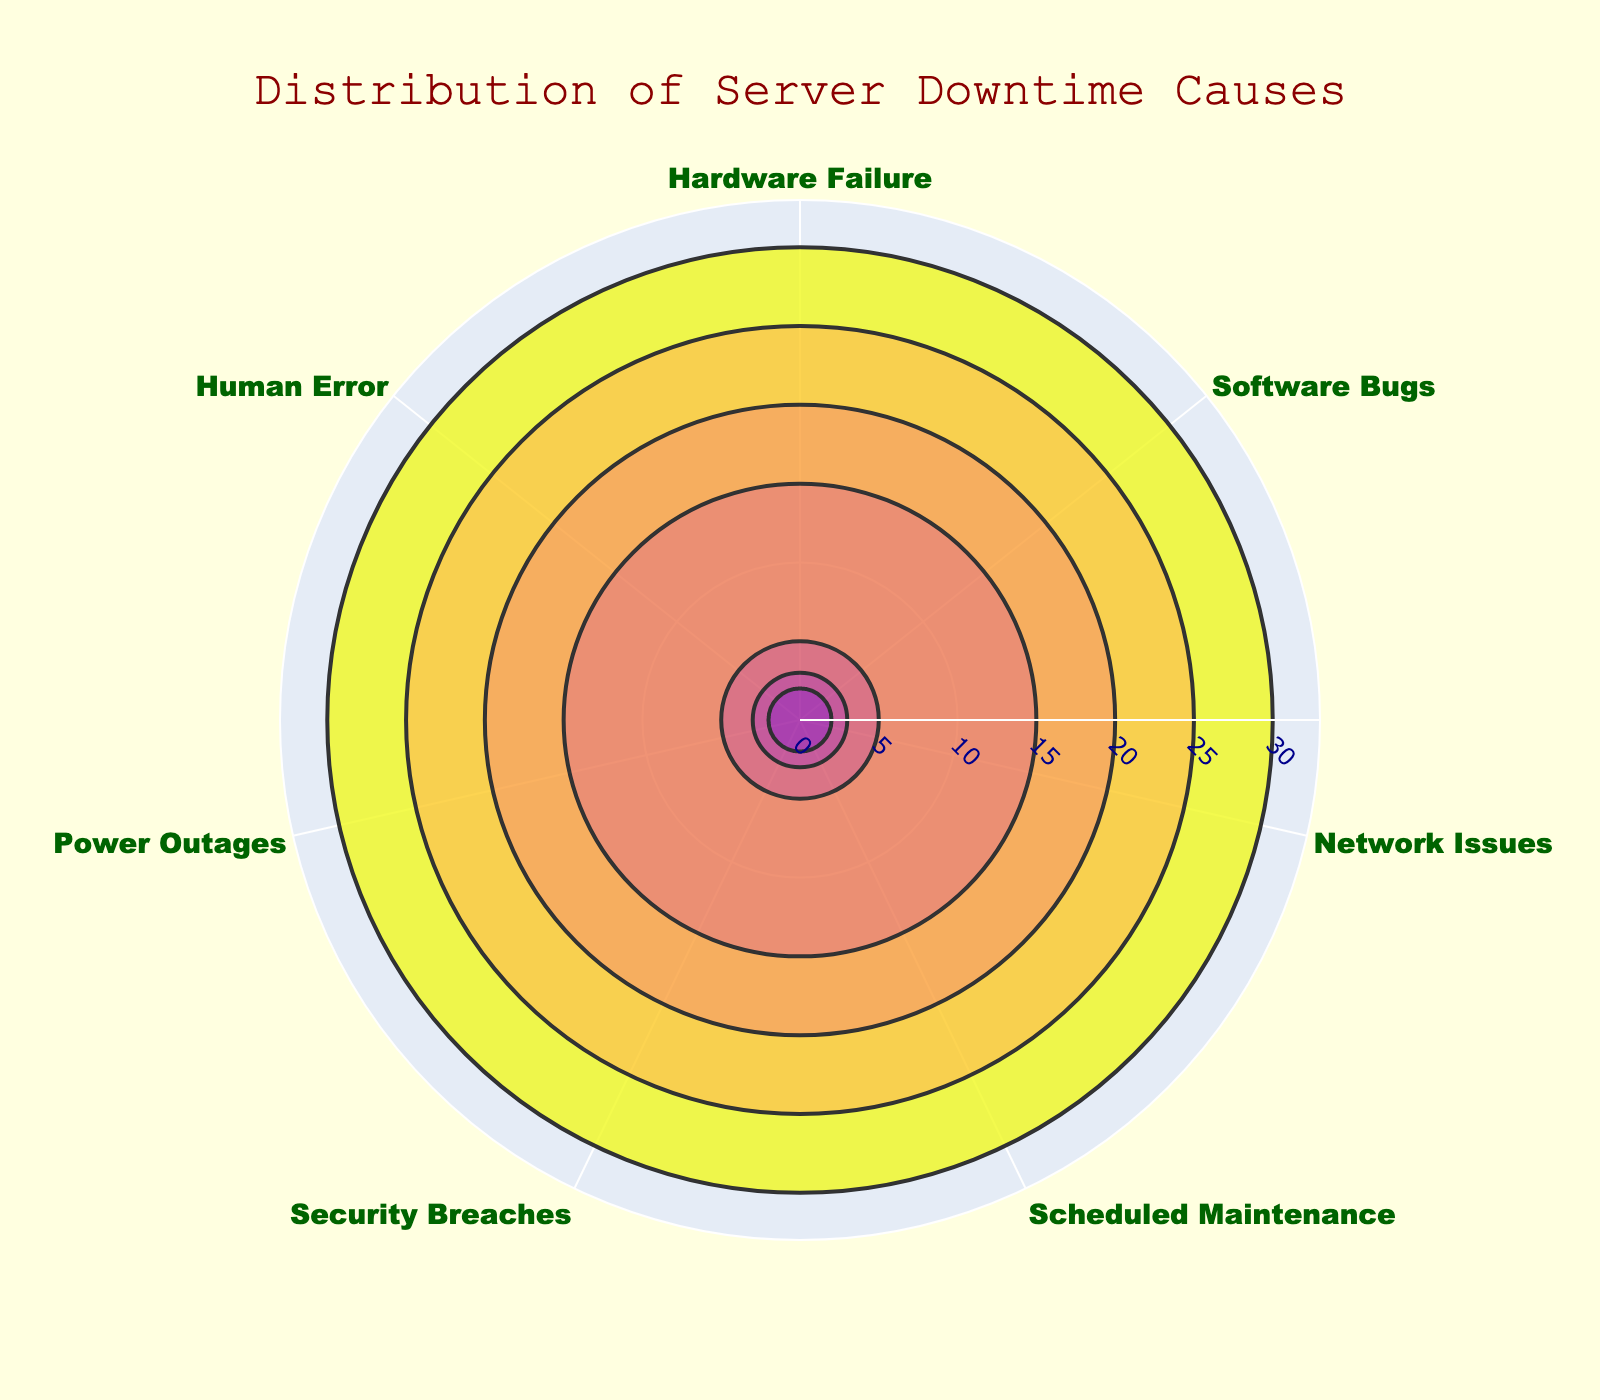What's the title of the chart? The title of the chart is clearly visible at the top and reads "Distribution of Server Downtime Causes."
Answer: Distribution of Server Downtime Causes Which cause has the highest percentage of server downtime? By observing the bars on the polar chart, the segment for "Hardware Failure" is the longest, indicating the highest percentage.
Answer: Hardware Failure What is the combined percentage of server downtime caused by Software Bugs and Network Issues? Refer to the percentages for Software Bugs (25%) and Network Issues (20%). Adding them together gives 25% + 20% = 45%.
Answer: 45% How does the downtime caused by Human Error compare to that caused by Power Outages? The chart shows Human Error at 2% and Power Outages at 3%. Therefore, Power Outages cause a higher percentage of downtime than Human Error.
Answer: Power Outages cause more downtime What is the percentage difference between Scheduled Maintenance and Security Breaches? Scheduled Maintenance accounts for 15% and Security Breaches account for 5%. The difference is 15% - 5% = 10%.
Answer: 10% Which causes have a percentage less than 10%? The chart segments for Security Breaches (5%), Power Outages (3%), and Human Error (2%) are all less than 10%.
Answer: Security Breaches, Power Outages, Human Error What colors are used for the markers in the chart? The markers on the polar bar chart use a range of colors from the Plasma color scale, typically varying from lighter colors to darker colors.
Answer: Plasma color scale How many causes have a percentage equal to or greater than 20%? Reviewing the percentages, Hardware Failure (30%), Software Bugs (25%), and Network Issues (20%) all meet this criteria, totaling three causes.
Answer: 3 causes What's the percentage of server downtime not related to hardware or software issues? Summing the percentages of the other causes: Network Issues (20%), Scheduled Maintenance (15%), Security Breaches (5%), Power Outages (3%), Human Error (2%) gives 45%.
Answer: 45% How is the radial axis labeled in the chart? The radial axis is labeled with values indicating percentage ranges, visible against a light background for easier reading.
Answer: Percentage ranges 